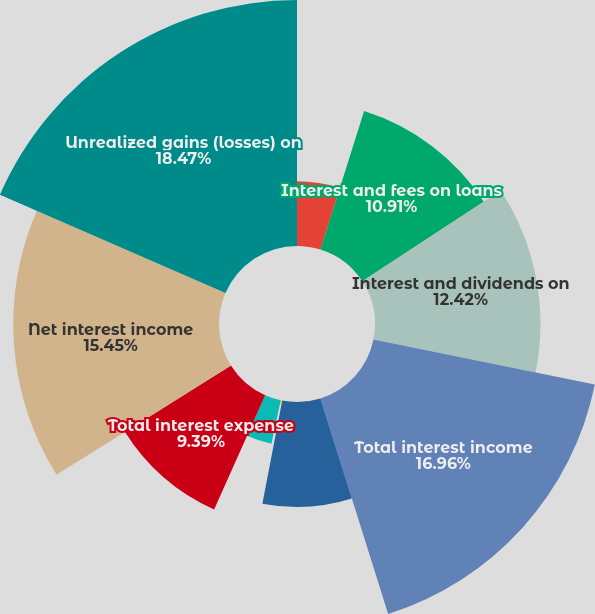Convert chart to OTSL. <chart><loc_0><loc_0><loc_500><loc_500><pie_chart><fcel>for the fiscal years ended<fcel>Interest and fees on loans<fcel>Interest and dividends on<fcel>Total interest income<fcel>Interest on deposits<fcel>Interest on short-term debt<fcel>Interest on long-term debt<fcel>Total interest expense<fcel>Net interest income<fcel>Unrealized gains (losses) on<nl><fcel>4.86%<fcel>10.91%<fcel>12.42%<fcel>16.96%<fcel>7.88%<fcel>0.32%<fcel>3.34%<fcel>9.39%<fcel>15.45%<fcel>18.47%<nl></chart> 